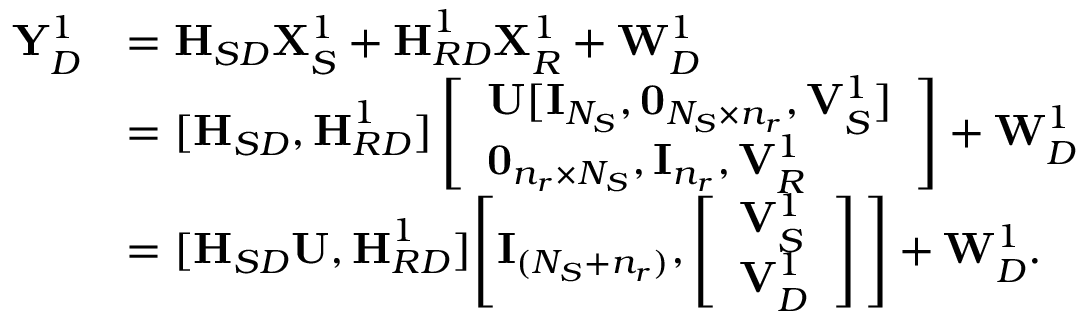<formula> <loc_0><loc_0><loc_500><loc_500>\begin{array} { r l } { { \mathbf Y } _ { D } ^ { 1 } } & { = { H } _ { S D } { \mathbf X } _ { S } ^ { 1 } + { H } _ { R D } ^ { 1 } { \mathbf X } _ { R } ^ { 1 } + { \mathbf W } _ { D } ^ { 1 } } \\ & { = [ { H } _ { S D } , { H } _ { R D } ^ { 1 } ] \left [ \begin{array} { l } { { \mathbf U } [ { \mathbf I } _ { N _ { S } } , 0 _ { N _ { S } \times n _ { r } } , { \mathbf V } _ { S } ^ { 1 } ] } \\ { 0 _ { n _ { r } \times N _ { S } } , { \mathbf I } _ { n _ { r } } , { \mathbf V } _ { R } ^ { 1 } } \end{array} \right ] + { \mathbf W } _ { D } ^ { 1 } } \\ & { = [ { H } _ { S D } { \mathbf U } , { H } _ { R D } ^ { 1 } ] \left [ { \mathbf I } _ { ( N _ { S } + n _ { r } ) } , \left [ \begin{array} { l } { { \mathbf V } _ { S } ^ { 1 } } \\ { { \mathbf V } _ { D } ^ { 1 } } \end{array} \right ] \right ] + { \mathbf W } _ { D } ^ { 1 } . } \end{array}</formula> 